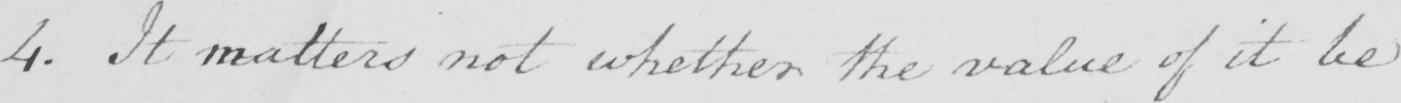Can you tell me what this handwritten text says? 4 . It matters not whether the value of it be 